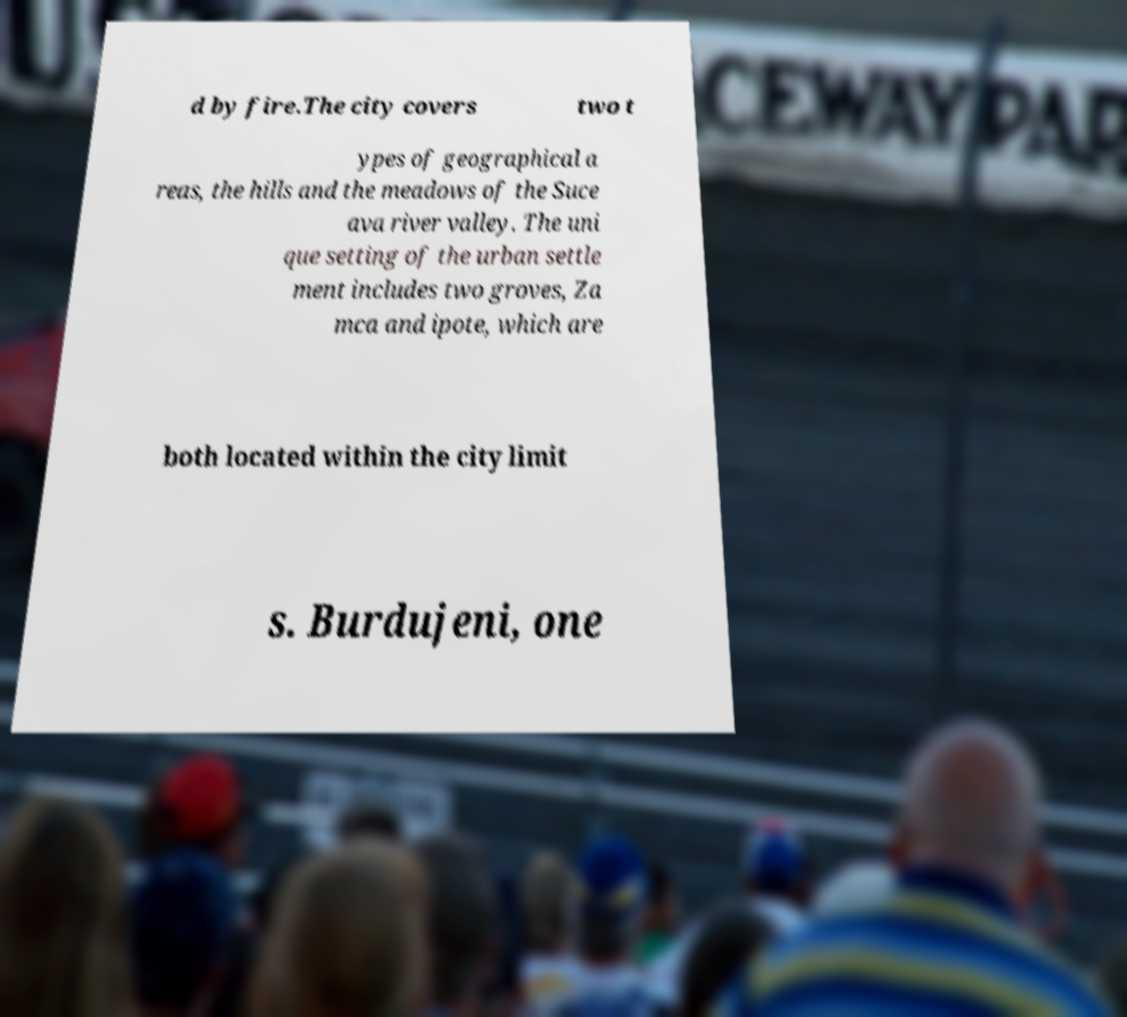Please identify and transcribe the text found in this image. d by fire.The city covers two t ypes of geographical a reas, the hills and the meadows of the Suce ava river valley. The uni que setting of the urban settle ment includes two groves, Za mca and ipote, which are both located within the city limit s. Burdujeni, one 